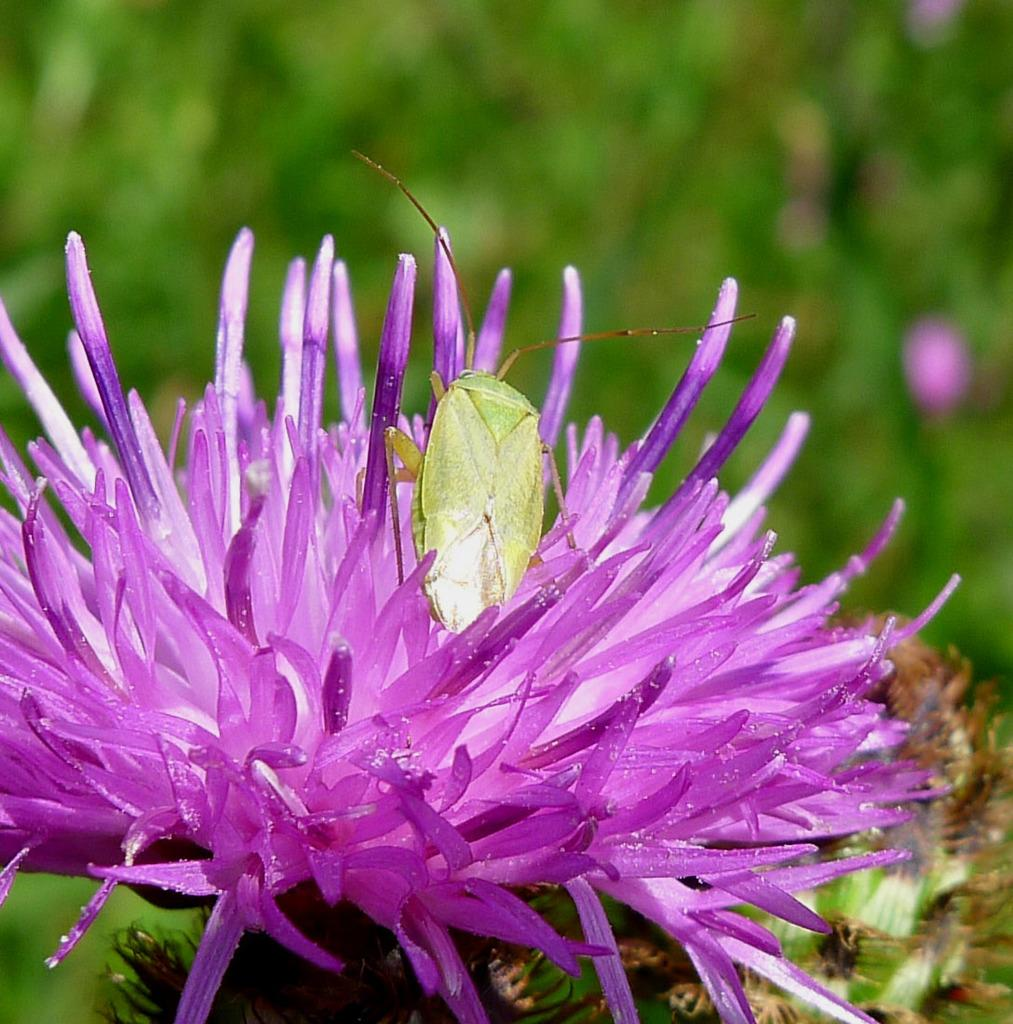What is the main subject of the image? There is an insect on a flower in the image. What can be seen in the background of the image? There are leaves visible in the background of the image. How would you describe the background of the image? The background appears blurry. How many children are playing in the rainstorm in the image? There is no rainstorm or children present in the image; it features an insect on a flower with a blurry background. 